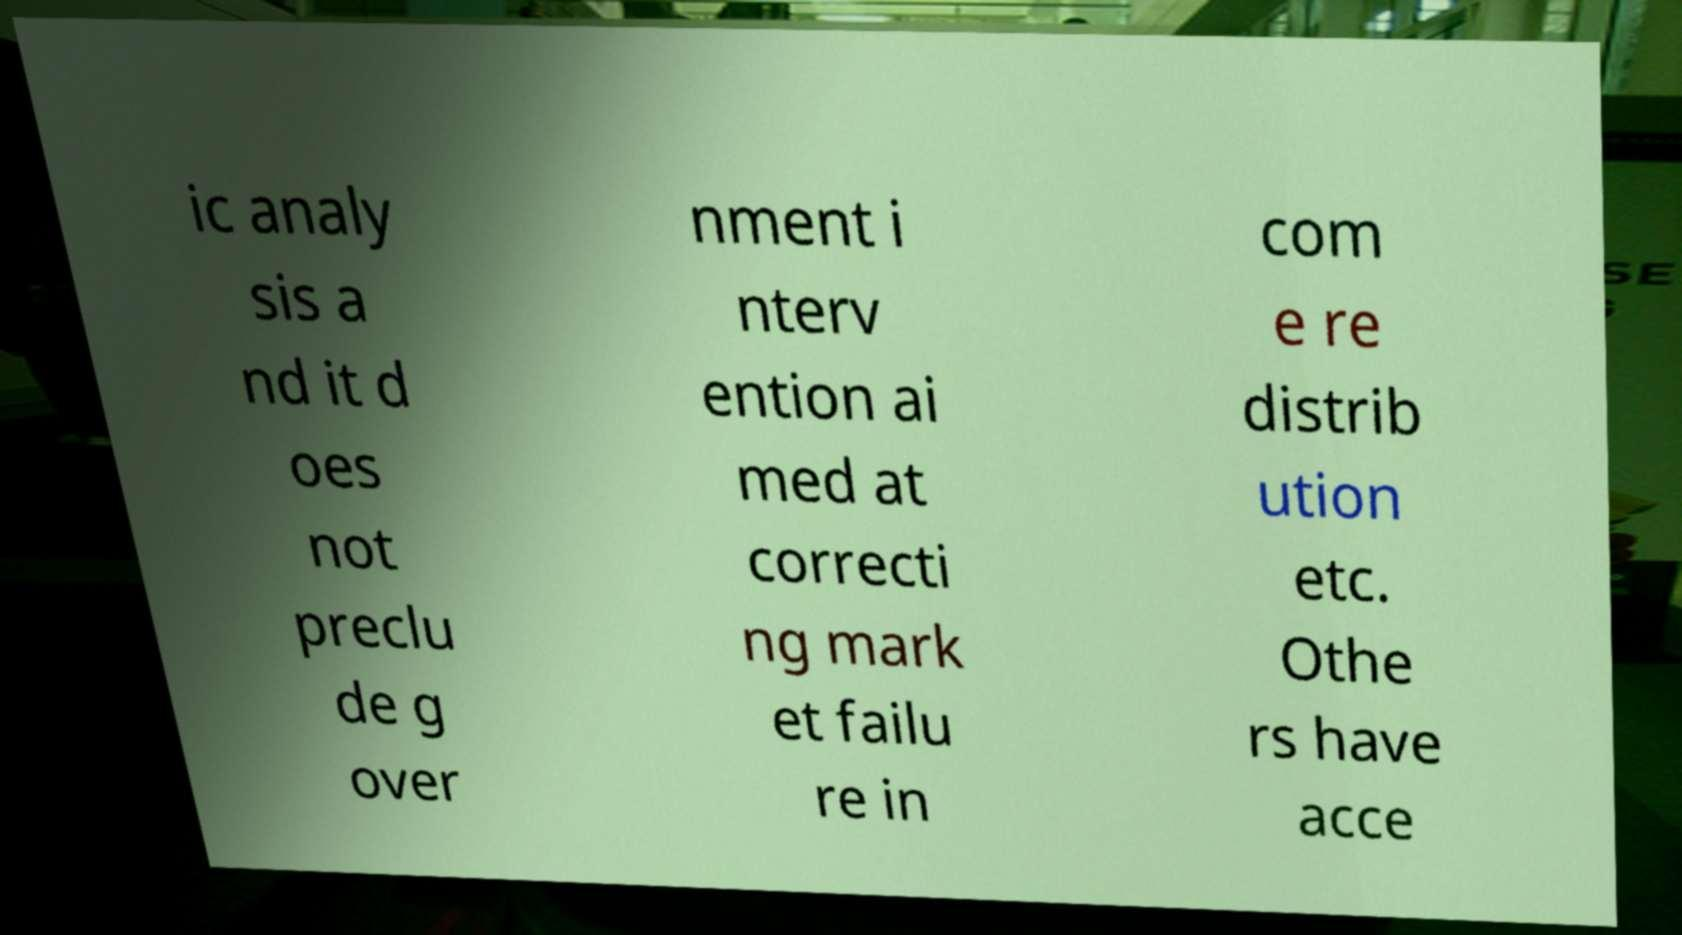Can you accurately transcribe the text from the provided image for me? ic analy sis a nd it d oes not preclu de g over nment i nterv ention ai med at correcti ng mark et failu re in com e re distrib ution etc. Othe rs have acce 